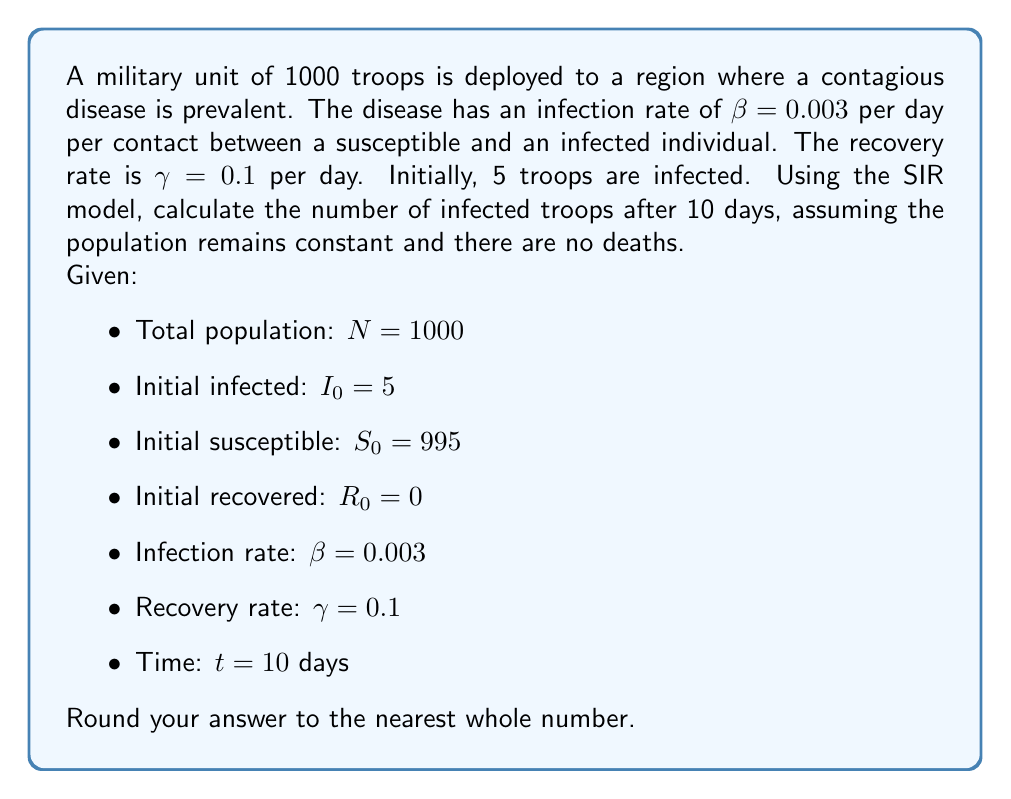Can you solve this math problem? To solve this problem, we'll use the SIR (Susceptible, Infected, Recovered) model, which is described by the following system of differential equations:

$$\begin{align}
\frac{dS}{dt} &= -\beta SI \\
\frac{dI}{dt} &= \beta SI - \gamma I \\
\frac{dR}{dt} &= \gamma I
\end{align}$$

Where:
- $S$ is the number of susceptible individuals
- $I$ is the number of infected individuals
- $R$ is the number of recovered individuals
- $t$ is time

To find the number of infected troops after 10 days, we need to solve these equations numerically. We can use the Euler method for approximation:

$$\begin{align}
S_{n+1} &= S_n - \beta S_n I_n \Delta t \\
I_{n+1} &= I_n + (\beta S_n I_n - \gamma I_n) \Delta t \\
R_{n+1} &= R_n + \gamma I_n \Delta t
\end{align}$$

Let's use a time step of $\Delta t = 0.1$ days, which means we'll perform 100 iterations to reach 10 days.

Here's a step-by-step calculation for the first few iterations:

1. Initial values:
   $S_0 = 995$, $I_0 = 5$, $R_0 = 0$

2. First iteration ($n = 0$):
   $S_1 = 995 - 0.003 \times 995 \times 5 \times 0.1 = 993.5075$
   $I_1 = 5 + (0.003 \times 995 \times 5 - 0.1 \times 5) \times 0.1 = 5.2425$
   $R_1 = 0 + 0.1 \times 5 \times 0.1 = 0.05$

3. Second iteration ($n = 1$):
   $S_2 = 993.5075 - 0.003 \times 993.5075 \times 5.2425 \times 0.1 = 991.9463$
   $I_2 = 5.2425 + (0.003 \times 993.5075 \times 5.2425 - 0.1 \times 5.2425) \times 0.1 = 5.4998$
   $R_2 = 0.05 + 0.1 \times 5.2425 \times 0.1 = 0.1024$

We continue this process for 100 iterations to reach 10 days. The final values after 10 days are:

$S_{100} \approx 808.5$
$I_{100} \approx 155.8$
$R_{100} \approx 35.7$

Rounding to the nearest whole number, we get 156 infected troops after 10 days.
Answer: 156 infected troops 